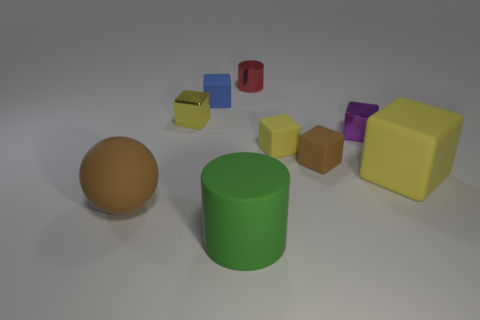What color is the big ball that is the same material as the green thing?
Make the answer very short. Brown. Is the number of tiny yellow matte cubes less than the number of yellow matte cubes?
Provide a succinct answer. Yes. There is a brown object that is on the left side of the small blue matte cube; does it have the same shape as the tiny yellow object that is on the right side of the large matte cylinder?
Offer a very short reply. No. What number of objects are either tiny yellow blocks or brown matte balls?
Your answer should be compact. 3. What is the color of the other metal block that is the same size as the yellow metallic cube?
Give a very brief answer. Purple. There is a yellow thing to the right of the purple metallic object; what number of big yellow blocks are in front of it?
Offer a terse response. 0. How many small rubber objects are both to the left of the green matte object and right of the small blue block?
Provide a short and direct response. 0. What number of things are yellow cubes on the right side of the tiny red metal thing or things to the left of the tiny blue block?
Provide a short and direct response. 4. How many other objects are there of the same size as the red cylinder?
Your answer should be very brief. 5. What shape is the tiny metallic object that is behind the small metal cube left of the small red cylinder?
Provide a succinct answer. Cylinder. 